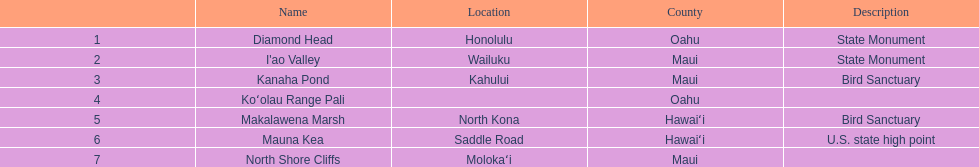Could you parse the entire table as a dict? {'header': ['', 'Name', 'Location', 'County', 'Description'], 'rows': [['1', 'Diamond Head', 'Honolulu', 'Oahu', 'State Monument'], ['2', "I'ao Valley", 'Wailuku', 'Maui', 'State Monument'], ['3', 'Kanaha Pond', 'Kahului', 'Maui', 'Bird Sanctuary'], ['4', 'Koʻolau Range Pali', '', 'Oahu', ''], ['5', 'Makalawena Marsh', 'North Kona', 'Hawaiʻi', 'Bird Sanctuary'], ['6', 'Mauna Kea', 'Saddle Road', 'Hawaiʻi', 'U.S. state high point'], ['7', 'North Shore Cliffs', 'Molokaʻi', 'Maui', '']]} How many images are listed? 6. 